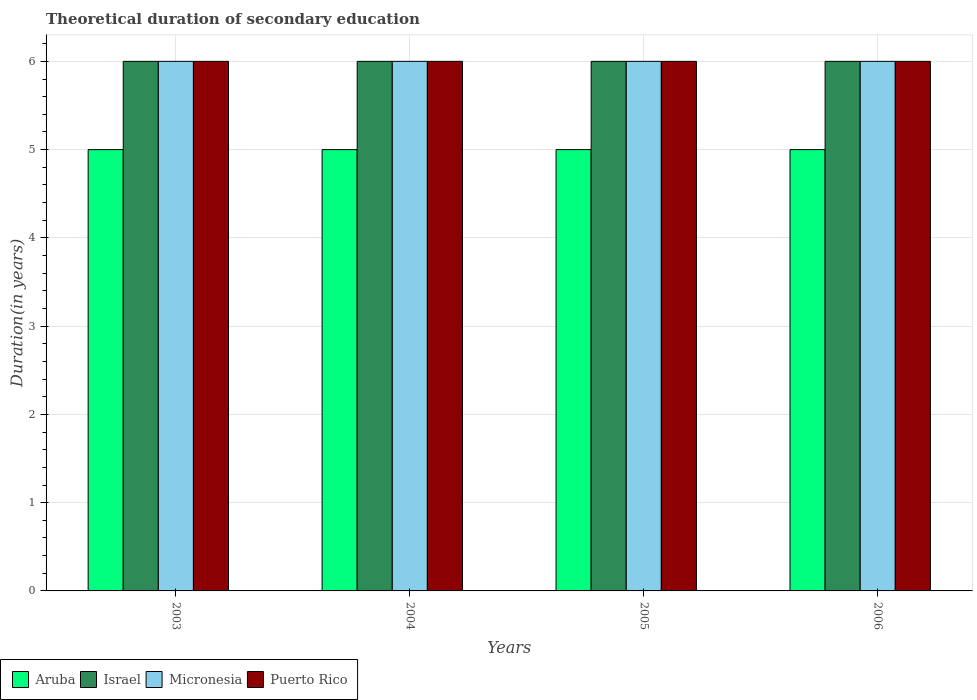Are the number of bars on each tick of the X-axis equal?
Ensure brevity in your answer.  Yes. How many bars are there on the 4th tick from the right?
Provide a succinct answer. 4. In how many cases, is the number of bars for a given year not equal to the number of legend labels?
Your response must be concise. 0. What is the total theoretical duration of secondary education in Aruba in 2004?
Your response must be concise. 5. Across all years, what is the maximum total theoretical duration of secondary education in Israel?
Your answer should be very brief. 6. Across all years, what is the minimum total theoretical duration of secondary education in Aruba?
Offer a terse response. 5. In which year was the total theoretical duration of secondary education in Puerto Rico minimum?
Your response must be concise. 2003. What is the total total theoretical duration of secondary education in Aruba in the graph?
Give a very brief answer. 20. What is the difference between the total theoretical duration of secondary education in Israel in 2003 and that in 2004?
Offer a very short reply. 0. What is the difference between the total theoretical duration of secondary education in Micronesia in 2003 and the total theoretical duration of secondary education in Puerto Rico in 2005?
Your response must be concise. 0. In the year 2003, what is the difference between the total theoretical duration of secondary education in Puerto Rico and total theoretical duration of secondary education in Aruba?
Keep it short and to the point. 1. What is the ratio of the total theoretical duration of secondary education in Aruba in 2003 to that in 2004?
Provide a short and direct response. 1. Is the difference between the total theoretical duration of secondary education in Puerto Rico in 2003 and 2006 greater than the difference between the total theoretical duration of secondary education in Aruba in 2003 and 2006?
Your answer should be compact. No. Is the sum of the total theoretical duration of secondary education in Israel in 2004 and 2005 greater than the maximum total theoretical duration of secondary education in Aruba across all years?
Your answer should be very brief. Yes. Is it the case that in every year, the sum of the total theoretical duration of secondary education in Aruba and total theoretical duration of secondary education in Israel is greater than the sum of total theoretical duration of secondary education in Micronesia and total theoretical duration of secondary education in Puerto Rico?
Ensure brevity in your answer.  Yes. What does the 1st bar from the left in 2004 represents?
Your response must be concise. Aruba. What does the 1st bar from the right in 2003 represents?
Offer a terse response. Puerto Rico. How many bars are there?
Provide a short and direct response. 16. What is the difference between two consecutive major ticks on the Y-axis?
Provide a succinct answer. 1. Where does the legend appear in the graph?
Keep it short and to the point. Bottom left. How many legend labels are there?
Keep it short and to the point. 4. What is the title of the graph?
Give a very brief answer. Theoretical duration of secondary education. What is the label or title of the Y-axis?
Offer a terse response. Duration(in years). What is the Duration(in years) of Aruba in 2003?
Your answer should be compact. 5. What is the Duration(in years) in Israel in 2003?
Keep it short and to the point. 6. What is the Duration(in years) of Micronesia in 2003?
Make the answer very short. 6. What is the Duration(in years) in Israel in 2004?
Give a very brief answer. 6. What is the Duration(in years) of Micronesia in 2004?
Your response must be concise. 6. What is the Duration(in years) in Puerto Rico in 2004?
Offer a terse response. 6. What is the Duration(in years) in Aruba in 2005?
Provide a succinct answer. 5. What is the Duration(in years) in Israel in 2005?
Your answer should be very brief. 6. What is the Duration(in years) of Micronesia in 2005?
Your answer should be very brief. 6. What is the Duration(in years) of Puerto Rico in 2005?
Your response must be concise. 6. What is the Duration(in years) of Aruba in 2006?
Your answer should be compact. 5. What is the Duration(in years) of Micronesia in 2006?
Your answer should be very brief. 6. Across all years, what is the maximum Duration(in years) in Israel?
Provide a succinct answer. 6. Across all years, what is the maximum Duration(in years) in Puerto Rico?
Offer a terse response. 6. Across all years, what is the minimum Duration(in years) in Aruba?
Make the answer very short. 5. Across all years, what is the minimum Duration(in years) in Micronesia?
Ensure brevity in your answer.  6. What is the total Duration(in years) of Israel in the graph?
Your answer should be very brief. 24. What is the total Duration(in years) of Micronesia in the graph?
Make the answer very short. 24. What is the difference between the Duration(in years) of Aruba in 2003 and that in 2004?
Keep it short and to the point. 0. What is the difference between the Duration(in years) of Aruba in 2003 and that in 2005?
Provide a succinct answer. 0. What is the difference between the Duration(in years) in Israel in 2003 and that in 2005?
Your answer should be compact. 0. What is the difference between the Duration(in years) of Micronesia in 2003 and that in 2005?
Provide a short and direct response. 0. What is the difference between the Duration(in years) of Puerto Rico in 2003 and that in 2005?
Keep it short and to the point. 0. What is the difference between the Duration(in years) in Aruba in 2003 and that in 2006?
Your answer should be compact. 0. What is the difference between the Duration(in years) in Micronesia in 2003 and that in 2006?
Provide a succinct answer. 0. What is the difference between the Duration(in years) in Puerto Rico in 2003 and that in 2006?
Give a very brief answer. 0. What is the difference between the Duration(in years) of Puerto Rico in 2004 and that in 2005?
Make the answer very short. 0. What is the difference between the Duration(in years) in Israel in 2004 and that in 2006?
Provide a succinct answer. 0. What is the difference between the Duration(in years) in Micronesia in 2004 and that in 2006?
Provide a short and direct response. 0. What is the difference between the Duration(in years) in Aruba in 2005 and that in 2006?
Make the answer very short. 0. What is the difference between the Duration(in years) of Israel in 2005 and that in 2006?
Your answer should be compact. 0. What is the difference between the Duration(in years) in Micronesia in 2005 and that in 2006?
Make the answer very short. 0. What is the difference between the Duration(in years) in Aruba in 2003 and the Duration(in years) in Puerto Rico in 2004?
Make the answer very short. -1. What is the difference between the Duration(in years) in Aruba in 2003 and the Duration(in years) in Israel in 2005?
Your answer should be compact. -1. What is the difference between the Duration(in years) of Micronesia in 2003 and the Duration(in years) of Puerto Rico in 2005?
Offer a very short reply. 0. What is the difference between the Duration(in years) in Aruba in 2003 and the Duration(in years) in Micronesia in 2006?
Make the answer very short. -1. What is the difference between the Duration(in years) in Aruba in 2003 and the Duration(in years) in Puerto Rico in 2006?
Your answer should be very brief. -1. What is the difference between the Duration(in years) of Aruba in 2004 and the Duration(in years) of Israel in 2005?
Your response must be concise. -1. What is the difference between the Duration(in years) of Aruba in 2004 and the Duration(in years) of Israel in 2006?
Offer a terse response. -1. What is the difference between the Duration(in years) of Aruba in 2004 and the Duration(in years) of Micronesia in 2006?
Give a very brief answer. -1. What is the difference between the Duration(in years) in Aruba in 2004 and the Duration(in years) in Puerto Rico in 2006?
Keep it short and to the point. -1. What is the difference between the Duration(in years) in Israel in 2004 and the Duration(in years) in Puerto Rico in 2006?
Provide a succinct answer. 0. What is the difference between the Duration(in years) of Aruba in 2005 and the Duration(in years) of Israel in 2006?
Give a very brief answer. -1. What is the difference between the Duration(in years) of Micronesia in 2005 and the Duration(in years) of Puerto Rico in 2006?
Ensure brevity in your answer.  0. What is the average Duration(in years) in Aruba per year?
Make the answer very short. 5. What is the average Duration(in years) in Micronesia per year?
Your response must be concise. 6. What is the average Duration(in years) in Puerto Rico per year?
Ensure brevity in your answer.  6. In the year 2003, what is the difference between the Duration(in years) of Aruba and Duration(in years) of Micronesia?
Provide a succinct answer. -1. In the year 2003, what is the difference between the Duration(in years) in Aruba and Duration(in years) in Puerto Rico?
Provide a succinct answer. -1. In the year 2003, what is the difference between the Duration(in years) in Israel and Duration(in years) in Micronesia?
Make the answer very short. 0. In the year 2003, what is the difference between the Duration(in years) of Israel and Duration(in years) of Puerto Rico?
Provide a short and direct response. 0. In the year 2003, what is the difference between the Duration(in years) in Micronesia and Duration(in years) in Puerto Rico?
Your answer should be very brief. 0. In the year 2004, what is the difference between the Duration(in years) of Aruba and Duration(in years) of Micronesia?
Your response must be concise. -1. In the year 2004, what is the difference between the Duration(in years) in Israel and Duration(in years) in Micronesia?
Provide a succinct answer. 0. In the year 2005, what is the difference between the Duration(in years) of Aruba and Duration(in years) of Puerto Rico?
Offer a very short reply. -1. In the year 2005, what is the difference between the Duration(in years) in Israel and Duration(in years) in Micronesia?
Keep it short and to the point. 0. In the year 2005, what is the difference between the Duration(in years) in Micronesia and Duration(in years) in Puerto Rico?
Provide a succinct answer. 0. In the year 2006, what is the difference between the Duration(in years) of Aruba and Duration(in years) of Micronesia?
Keep it short and to the point. -1. In the year 2006, what is the difference between the Duration(in years) of Israel and Duration(in years) of Micronesia?
Make the answer very short. 0. What is the ratio of the Duration(in years) of Micronesia in 2003 to that in 2005?
Ensure brevity in your answer.  1. What is the ratio of the Duration(in years) in Puerto Rico in 2003 to that in 2005?
Provide a succinct answer. 1. What is the ratio of the Duration(in years) of Aruba in 2003 to that in 2006?
Your answer should be very brief. 1. What is the ratio of the Duration(in years) of Israel in 2003 to that in 2006?
Your response must be concise. 1. What is the ratio of the Duration(in years) of Aruba in 2004 to that in 2005?
Your response must be concise. 1. What is the ratio of the Duration(in years) in Micronesia in 2004 to that in 2005?
Your answer should be very brief. 1. What is the ratio of the Duration(in years) in Israel in 2004 to that in 2006?
Offer a terse response. 1. What is the ratio of the Duration(in years) of Micronesia in 2004 to that in 2006?
Your answer should be very brief. 1. What is the ratio of the Duration(in years) in Israel in 2005 to that in 2006?
Ensure brevity in your answer.  1. What is the ratio of the Duration(in years) of Micronesia in 2005 to that in 2006?
Give a very brief answer. 1. What is the ratio of the Duration(in years) of Puerto Rico in 2005 to that in 2006?
Offer a very short reply. 1. What is the difference between the highest and the second highest Duration(in years) of Puerto Rico?
Provide a short and direct response. 0. What is the difference between the highest and the lowest Duration(in years) of Aruba?
Your answer should be very brief. 0. 